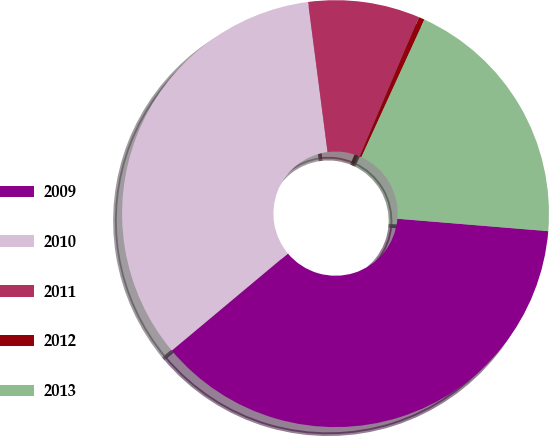Convert chart. <chart><loc_0><loc_0><loc_500><loc_500><pie_chart><fcel>2009<fcel>2010<fcel>2011<fcel>2012<fcel>2013<nl><fcel>37.6%<fcel>34.03%<fcel>8.45%<fcel>0.44%<fcel>19.47%<nl></chart> 